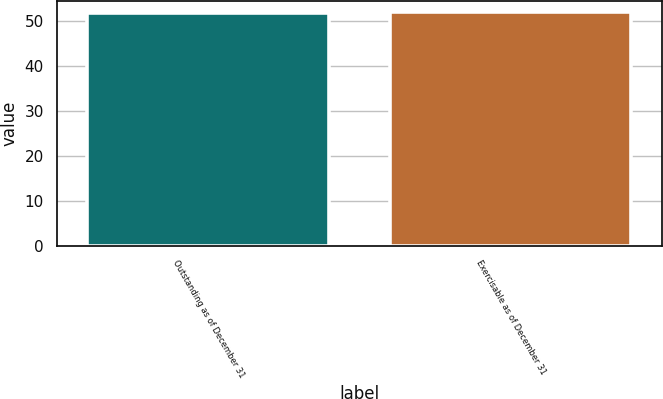<chart> <loc_0><loc_0><loc_500><loc_500><bar_chart><fcel>Outstanding as of December 31<fcel>Exercisable as of December 31<nl><fcel>51.76<fcel>52.01<nl></chart> 